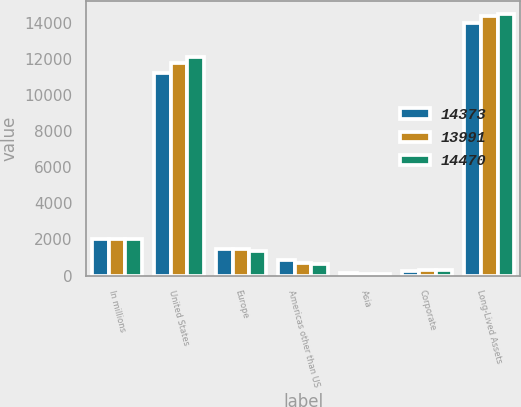Convert chart to OTSL. <chart><loc_0><loc_0><loc_500><loc_500><stacked_bar_chart><ecel><fcel>In millions<fcel>United States<fcel>Europe<fcel>Americas other than US<fcel>Asia<fcel>Corporate<fcel>Long-Lived Assets<nl><fcel>14373<fcel>2005<fcel>11218<fcel>1474<fcel>875<fcel>142<fcel>282<fcel>13991<nl><fcel>13991<fcel>2004<fcel>11764<fcel>1489<fcel>718<fcel>114<fcel>288<fcel>14373<nl><fcel>14470<fcel>2003<fcel>12102<fcel>1334<fcel>629<fcel>98<fcel>307<fcel>14470<nl></chart> 